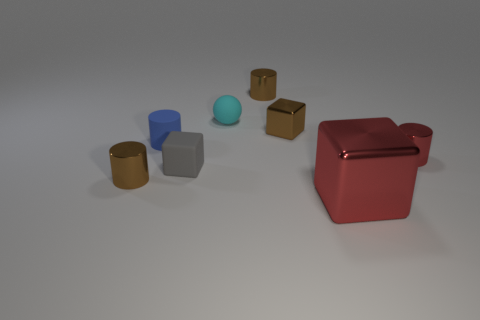Subtract all green balls. How many brown cylinders are left? 2 Subtract 2 cylinders. How many cylinders are left? 2 Subtract all tiny blue cylinders. How many cylinders are left? 3 Add 1 brown shiny cylinders. How many objects exist? 9 Subtract all yellow cylinders. Subtract all purple balls. How many cylinders are left? 4 Add 8 green rubber spheres. How many green rubber spheres exist? 8 Subtract 0 cyan cubes. How many objects are left? 8 Subtract all blocks. How many objects are left? 5 Subtract all small rubber balls. Subtract all small cyan rubber things. How many objects are left? 6 Add 5 tiny red metal cylinders. How many tiny red metal cylinders are left? 6 